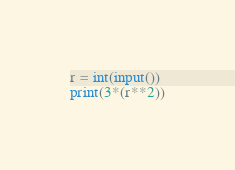Convert code to text. <code><loc_0><loc_0><loc_500><loc_500><_Python_>r = int(input())
print(3*(r**2))
</code> 